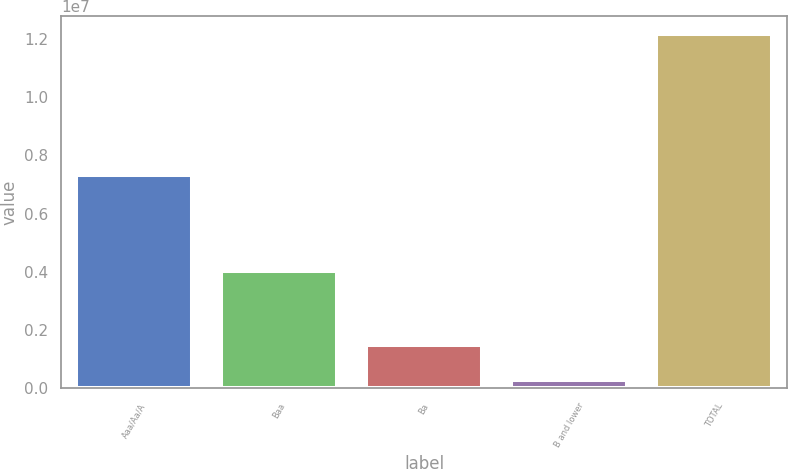Convert chart. <chart><loc_0><loc_0><loc_500><loc_500><bar_chart><fcel>Aaa/Aa/A<fcel>Baa<fcel>Ba<fcel>B and lower<fcel>TOTAL<nl><fcel>7.31901e+06<fcel>4.01461e+06<fcel>1.48291e+06<fcel>295270<fcel>1.21716e+07<nl></chart> 